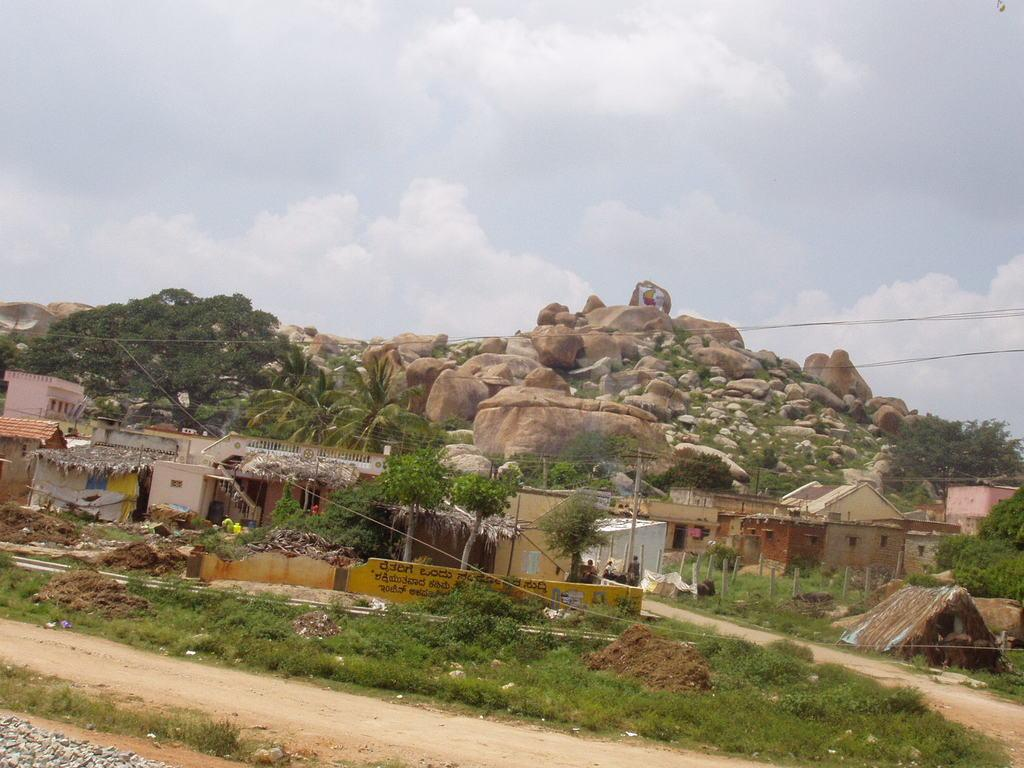What type of vegetation can be seen in the image? There is grass, plants, and trees visible in the image. What type of structures are present in the image? There are houses and huts in the image. What is the material of the wall in the image? The wall in the image is made of stones. What can be seen in the sky in the background of the image? The sky is visible in the background of the image, and there are clouds present. Can you see any dinosaurs or zebras in the image? No, there are no dinosaurs or zebras present in the image. What type of home does the zebra live in within the image? There is no zebra present in the image, so it is not possible to determine the type of home it might live in. 